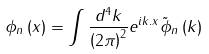<formula> <loc_0><loc_0><loc_500><loc_500>\phi _ { n } \left ( x \right ) = \int \frac { d ^ { 4 } k } { \left ( 2 \pi \right ) ^ { 2 } } e ^ { i k . x } \tilde { \phi } _ { n } \left ( k \right )</formula> 